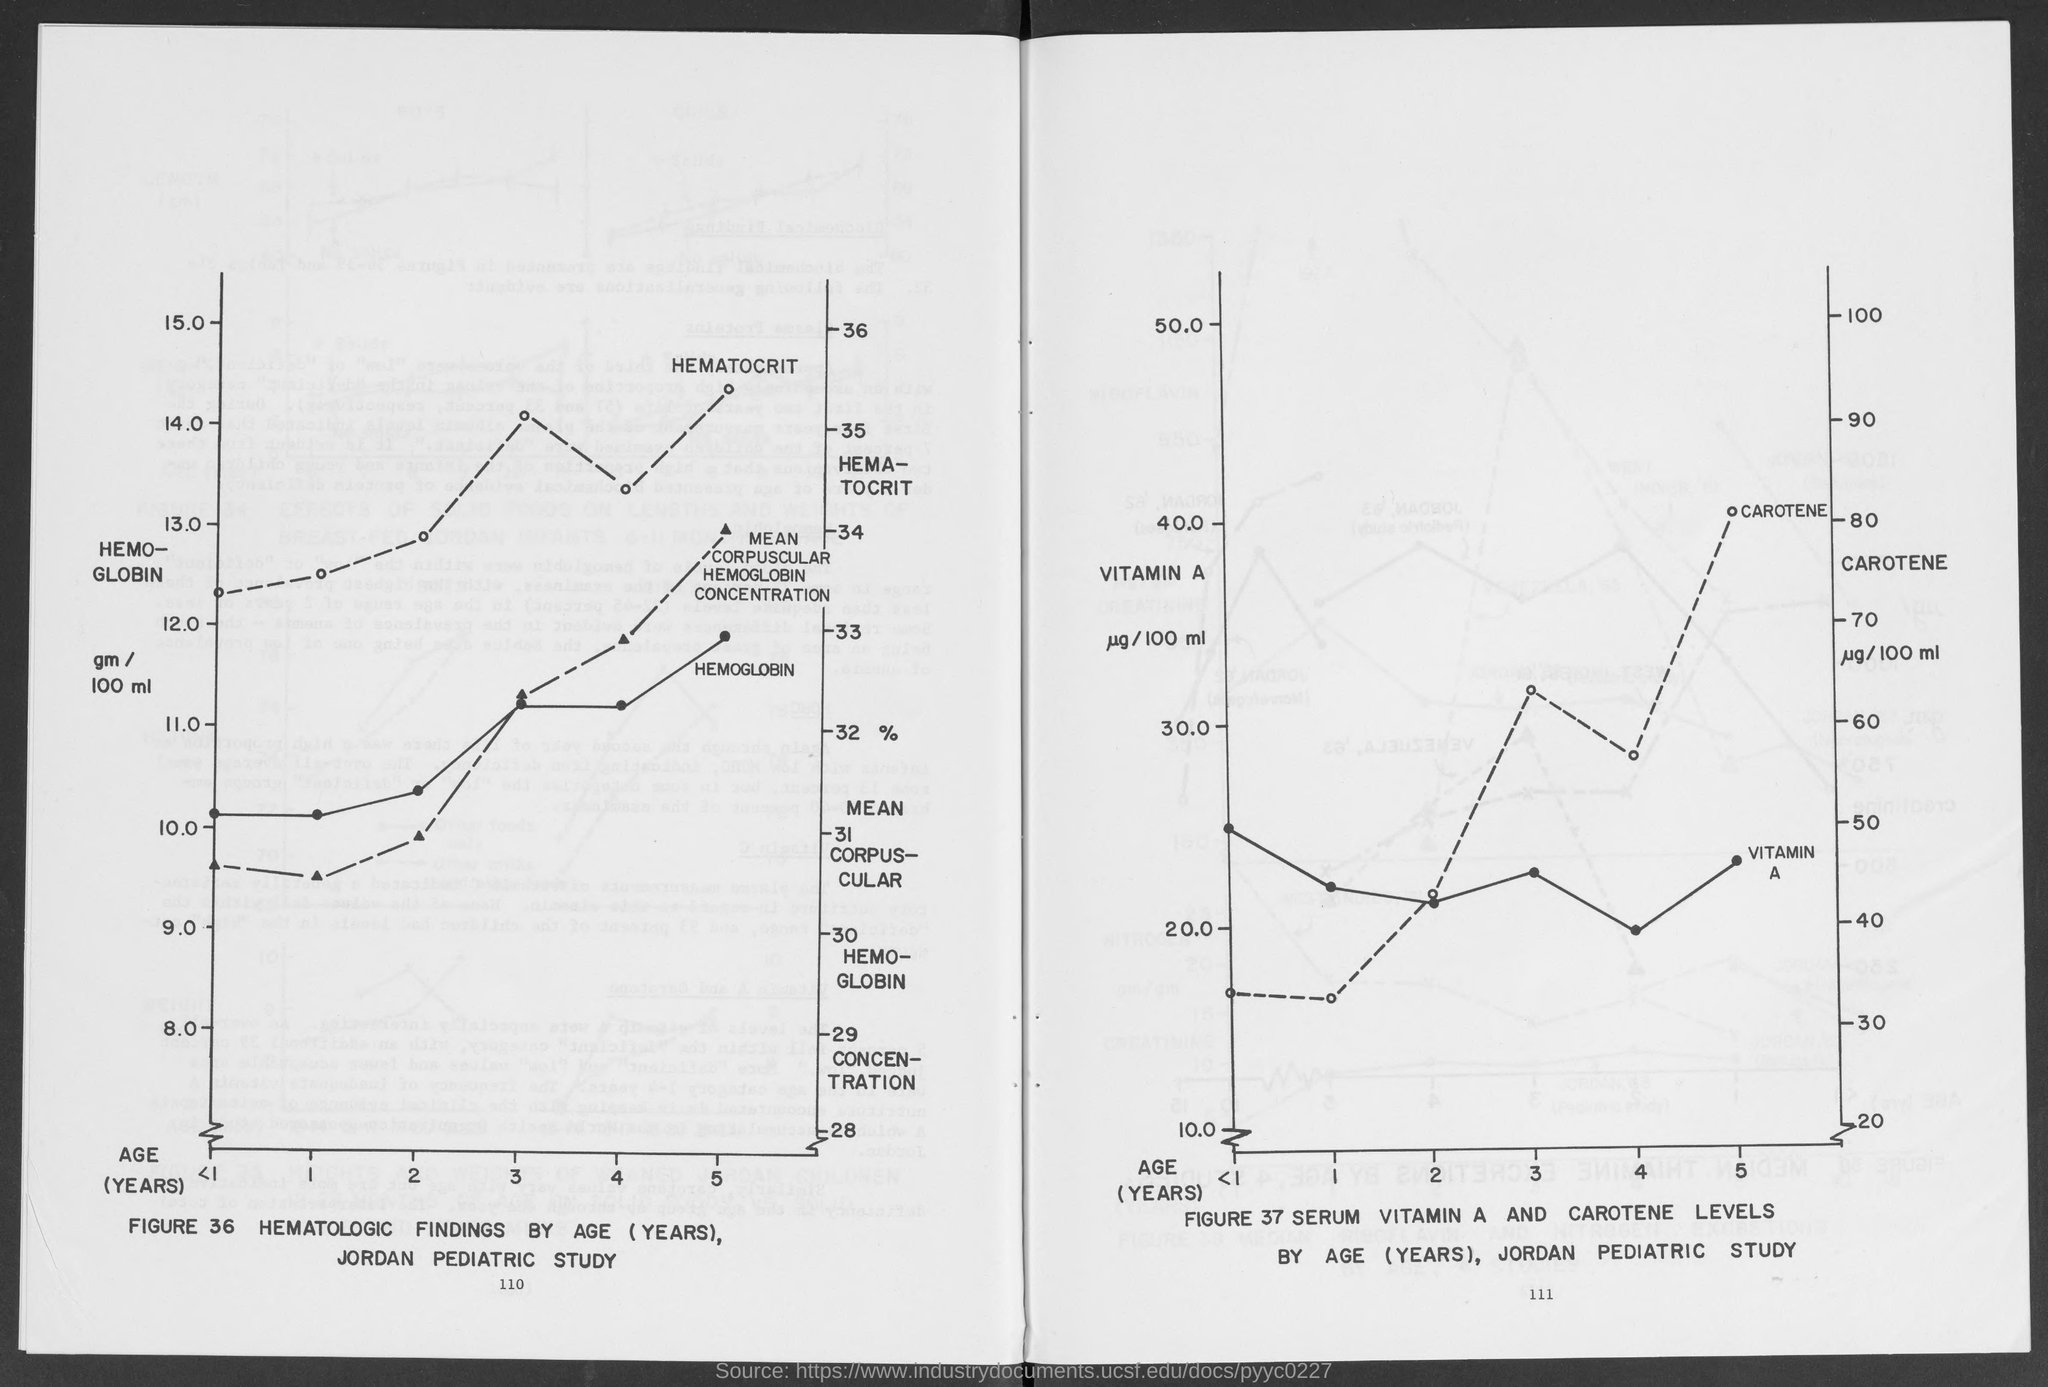Highlight a few significant elements in this photo. The minimum value of "HEMOGLOBIN gm / 100 ml" shown in FIGURE 36 is 8. The hematologic findings in the figure are shown based on age (years). The maximum AGE (YEARS) taken for study in Figure 37 is 5. The maximum value of hemoglobin, as shown in Figure 36, is 15.0. The study of vitamin A and carotenoid levels in children, conducted by the Jordan Pediatric Study, is depicted in Figure 37. 